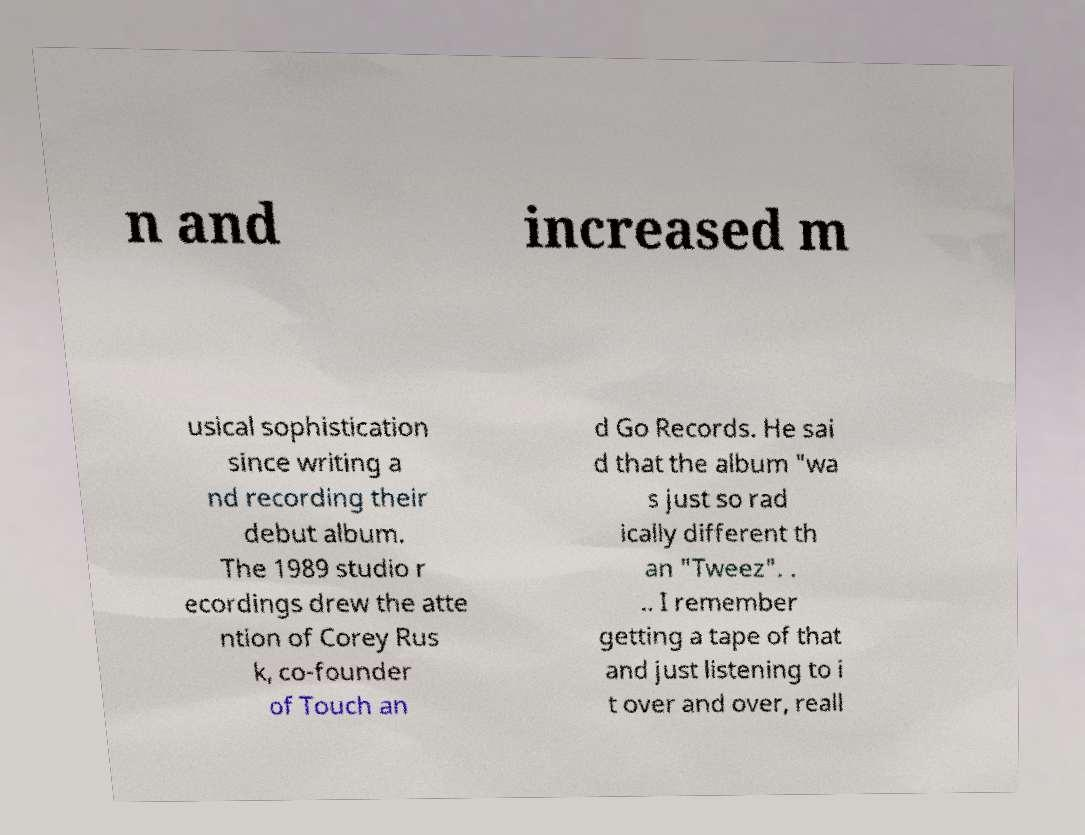Please identify and transcribe the text found in this image. n and increased m usical sophistication since writing a nd recording their debut album. The 1989 studio r ecordings drew the atte ntion of Corey Rus k, co-founder of Touch an d Go Records. He sai d that the album "wa s just so rad ically different th an "Tweez". . .. I remember getting a tape of that and just listening to i t over and over, reall 